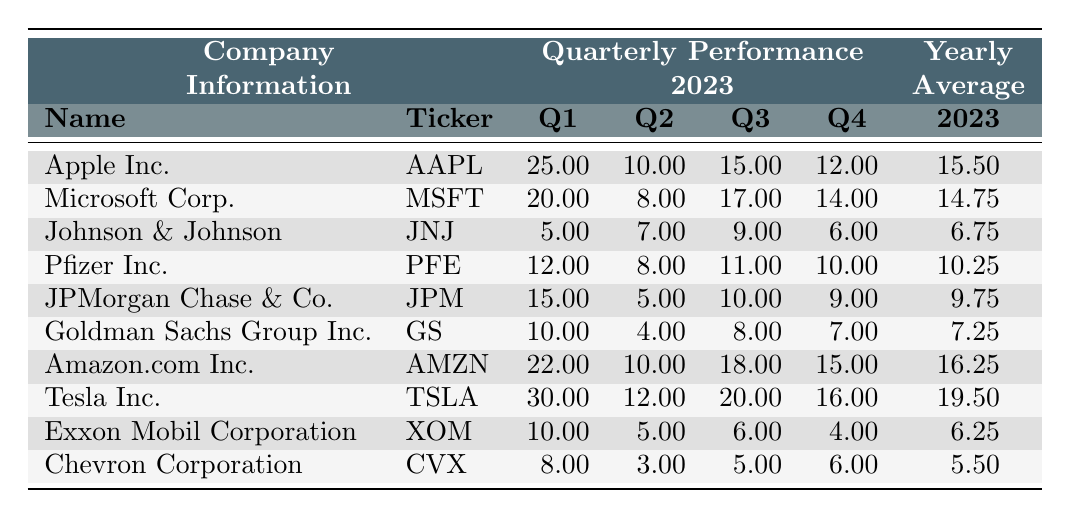What was the quarterly performance of Apple Inc. in Q2? Referring to the table, the value under the Q2 Performance column for Apple Inc. is 10%.
Answer: 10% Which company had the highest yearly average performance in 2023? By checking the Yearly Average column, Tesla Inc. has the highest average at 19.5%.
Answer: Tesla Inc What was the total average performance of the Finance sector? The average performance values for the Finance sector companies are 9.75% for JPMorgan Chase & Co. and 7.25% for Goldman Sachs Group Inc. Adding them gives 9.75 + 7.25 = 17, and dividing by 2 results in 17/2 = 8.5%.
Answer: 8.5% Did Pfizer Inc. perform better than Johnson & Johnson in every quarter? Comparing their quarterly performances: Pfizer Inc. had 12% (Q1), 8% (Q2), 11% (Q3), and 10% (Q4). Johnson & Johnson had 5% (Q1), 7% (Q2), 9% (Q3), and 6% (Q4). Pfizer performed better in Q1, Q3, and Q4, but not in Q2. Hence, the statement is false.
Answer: No What is the average Q3 performance of the Consumer Discretionary sector companies? The Q3 performances are 18% for Amazon.com Inc. and 20% for Tesla Inc. Adding these gives 18 + 20 = 38, and dividing by 2 gives 38/2 = 19%.
Answer: 19% Which sector had the lowest average performance and what was that average? Checking the yearly averages for each sector, the Energy sector has the lowest at 5.5%.
Answer: Energy sector, 5.5% If we compare the Q1 performances of Technology and Healthcare sectors, how much higher was Technology's average? The Q1 performances are 25% (Apple Inc.) and 20% (Microsoft Corp.) for Technology, giving an average of (25 + 20)/2 = 22.5%. For Healthcare, the average of 5% (JNJ) and 12% (PFE) is (5 + 12)/2 = 8.5%. The difference is 22.5 - 8.5 = 14%.
Answer: 14% Is the yearly average of Exxon Mobil Corporation above 6%? The Yearly Average for Exxon Mobil Corporation is 6.25%, which is above 6%. Therefore, the statement is true.
Answer: Yes What was the percentage change in performance from Q3 to Q4 for Tesla Inc.? For Tesla Inc., Q3 was 20% and Q4 was 16%. The percentage change formula is ((16 - 20) / 20) * 100, resulting in a change of -20%.
Answer: -20% Which company had the lowest quarterly performance in Q2 and what was it? Examining the Q2 Performance, Chevron Corporation has the lowest at 3%.
Answer: Chevron Corporation, 3% 